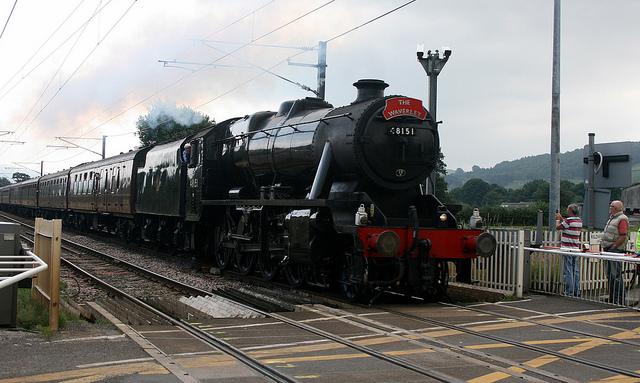Is this a passenger train?
Quick response, please. Yes. What number engine is this?
Concise answer only. 8151. What color is the train?
Keep it brief. Black. What is the train generating?
Concise answer only. Smoke. How many people in the photo?
Concise answer only. 2. What color are the poles?
Answer briefly. Gray. 